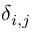Convert formula to latex. <formula><loc_0><loc_0><loc_500><loc_500>\delta _ { i , j }</formula> 